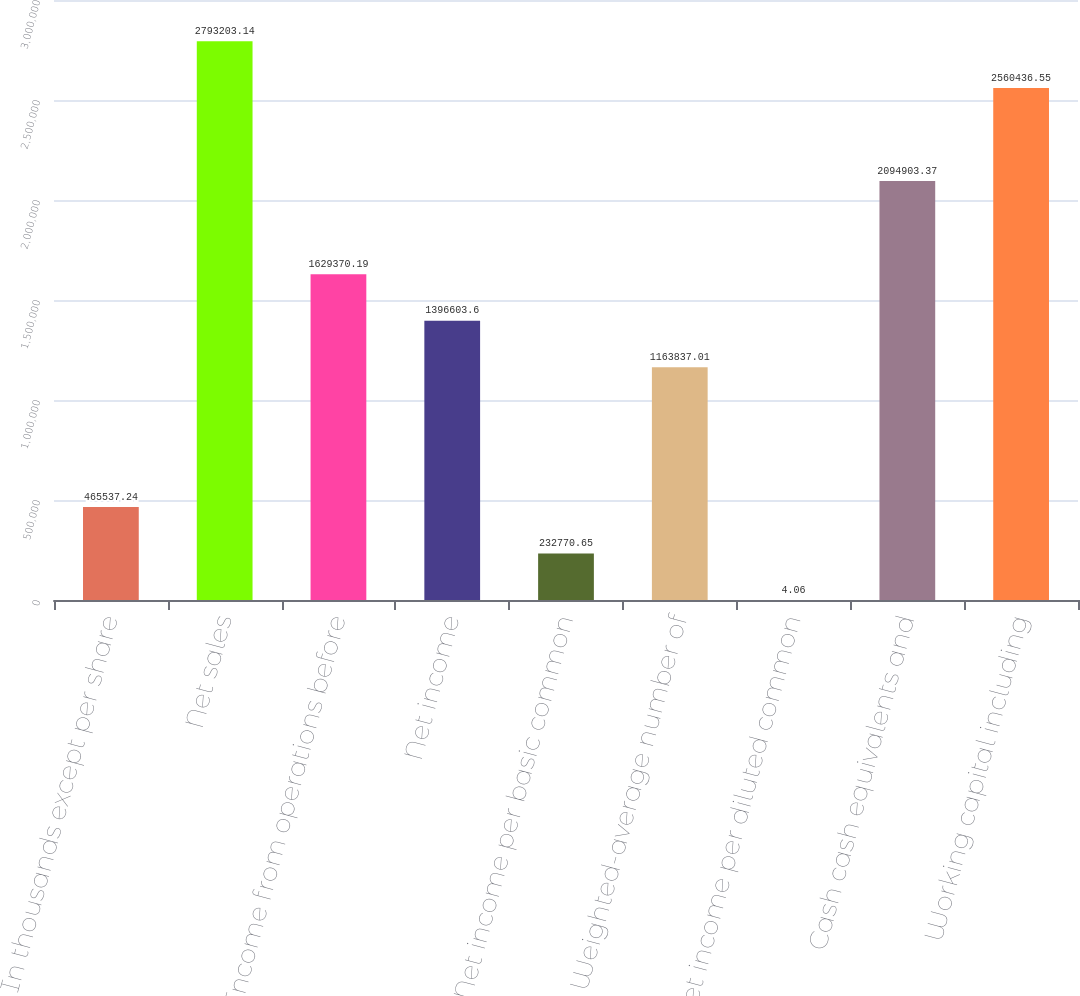Convert chart to OTSL. <chart><loc_0><loc_0><loc_500><loc_500><bar_chart><fcel>In thousands except per share<fcel>Net sales<fcel>Income from operations before<fcel>Net income<fcel>Net income per basic common<fcel>Weighted-average number of<fcel>Net income per diluted common<fcel>Cash cash equivalents and<fcel>Working capital including<nl><fcel>465537<fcel>2.7932e+06<fcel>1.62937e+06<fcel>1.3966e+06<fcel>232771<fcel>1.16384e+06<fcel>4.06<fcel>2.0949e+06<fcel>2.56044e+06<nl></chart> 